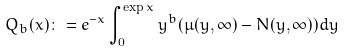Convert formula to latex. <formula><loc_0><loc_0><loc_500><loc_500>Q _ { b } ( x ) \colon = e ^ { - x } \int _ { 0 } ^ { \exp x } y ^ { b } ( \mu ( y , \infty ) - N ( y , \infty ) ) d y</formula> 